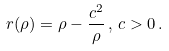Convert formula to latex. <formula><loc_0><loc_0><loc_500><loc_500>r ( \rho ) = \rho - \frac { c ^ { 2 } } { \rho } \, , \, c > 0 \, .</formula> 